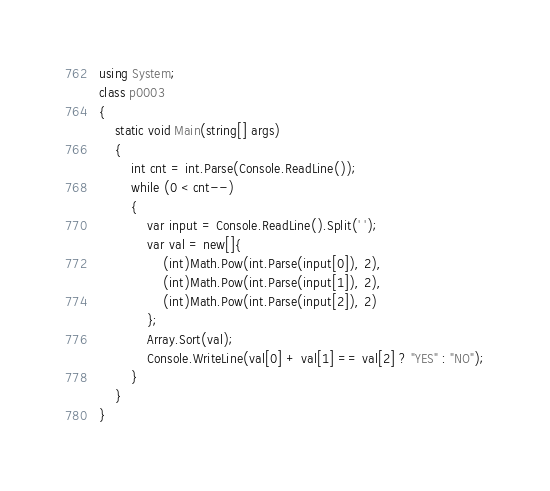Convert code to text. <code><loc_0><loc_0><loc_500><loc_500><_C#_>using System;
class p0003
{
    static void Main(string[] args)
    {
        int cnt = int.Parse(Console.ReadLine());
        while (0 < cnt--)
        {
            var input = Console.ReadLine().Split(' ');
            var val = new[]{
                (int)Math.Pow(int.Parse(input[0]), 2), 
                (int)Math.Pow(int.Parse(input[1]), 2),
                (int)Math.Pow(int.Parse(input[2]), 2)
            };
            Array.Sort(val);
            Console.WriteLine(val[0] + val[1] == val[2] ? "YES" : "NO");
        }
    }
}</code> 